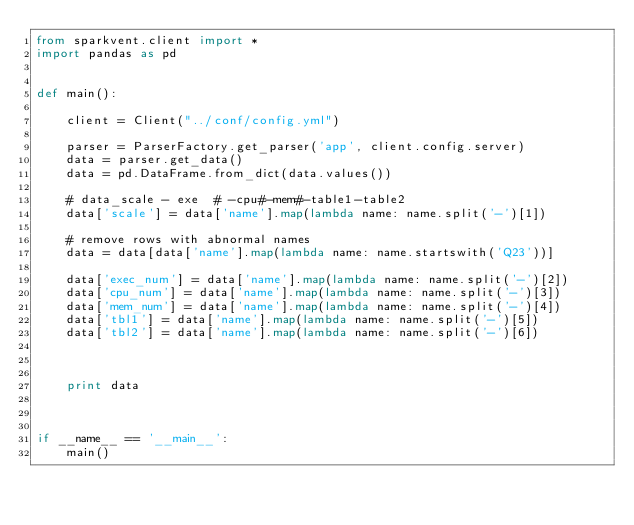Convert code to text. <code><loc_0><loc_0><loc_500><loc_500><_Python_>from sparkvent.client import *
import pandas as pd


def main():

    client = Client("../conf/config.yml")

    parser = ParserFactory.get_parser('app', client.config.server)
    data = parser.get_data()
    data = pd.DataFrame.from_dict(data.values())

    # data_scale - exe  # -cpu#-mem#-table1-table2
    data['scale'] = data['name'].map(lambda name: name.split('-')[1])

    # remove rows with abnormal names
    data = data[data['name'].map(lambda name: name.startswith('Q23'))]

    data['exec_num'] = data['name'].map(lambda name: name.split('-')[2])
    data['cpu_num'] = data['name'].map(lambda name: name.split('-')[3])
    data['mem_num'] = data['name'].map(lambda name: name.split('-')[4])
    data['tbl1'] = data['name'].map(lambda name: name.split('-')[5])
    data['tbl2'] = data['name'].map(lambda name: name.split('-')[6])



    print data



if __name__ == '__main__':
    main()
</code> 